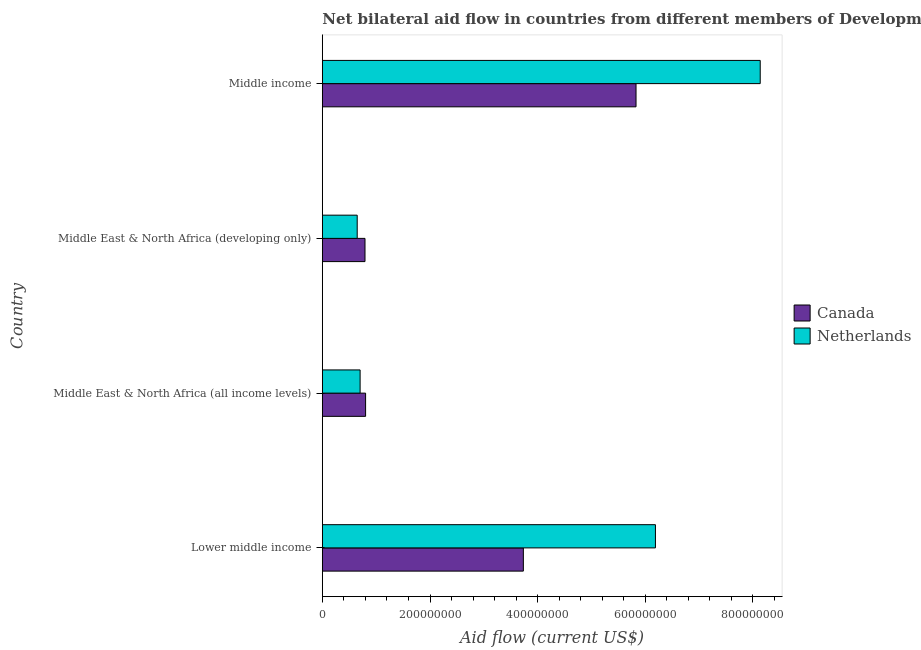Are the number of bars per tick equal to the number of legend labels?
Keep it short and to the point. Yes. How many bars are there on the 3rd tick from the top?
Offer a terse response. 2. What is the label of the 4th group of bars from the top?
Your answer should be very brief. Lower middle income. What is the amount of aid given by netherlands in Middle East & North Africa (all income levels)?
Provide a short and direct response. 7.02e+07. Across all countries, what is the maximum amount of aid given by netherlands?
Make the answer very short. 8.13e+08. Across all countries, what is the minimum amount of aid given by canada?
Provide a short and direct response. 7.93e+07. In which country was the amount of aid given by canada minimum?
Offer a very short reply. Middle East & North Africa (developing only). What is the total amount of aid given by netherlands in the graph?
Your answer should be compact. 1.57e+09. What is the difference between the amount of aid given by netherlands in Middle East & North Africa (all income levels) and that in Middle East & North Africa (developing only)?
Provide a succinct answer. 5.41e+06. What is the difference between the amount of aid given by canada in Middle income and the amount of aid given by netherlands in Middle East & North Africa (developing only)?
Provide a short and direct response. 5.18e+08. What is the average amount of aid given by netherlands per country?
Offer a terse response. 3.92e+08. What is the difference between the amount of aid given by netherlands and amount of aid given by canada in Middle income?
Provide a short and direct response. 2.31e+08. What is the ratio of the amount of aid given by netherlands in Lower middle income to that in Middle East & North Africa (developing only)?
Provide a short and direct response. 9.55. Is the difference between the amount of aid given by netherlands in Lower middle income and Middle East & North Africa (all income levels) greater than the difference between the amount of aid given by canada in Lower middle income and Middle East & North Africa (all income levels)?
Ensure brevity in your answer.  Yes. What is the difference between the highest and the second highest amount of aid given by canada?
Your answer should be very brief. 2.09e+08. What is the difference between the highest and the lowest amount of aid given by netherlands?
Your answer should be very brief. 7.49e+08. What does the 1st bar from the top in Middle income represents?
Your answer should be compact. Netherlands. Are all the bars in the graph horizontal?
Your answer should be compact. Yes. What is the difference between two consecutive major ticks on the X-axis?
Provide a succinct answer. 2.00e+08. Where does the legend appear in the graph?
Keep it short and to the point. Center right. How many legend labels are there?
Offer a terse response. 2. How are the legend labels stacked?
Provide a short and direct response. Vertical. What is the title of the graph?
Your answer should be very brief. Net bilateral aid flow in countries from different members of Development Assistance Committee. Does "Current US$" appear as one of the legend labels in the graph?
Your answer should be compact. No. What is the label or title of the Y-axis?
Provide a succinct answer. Country. What is the Aid flow (current US$) in Canada in Lower middle income?
Provide a succinct answer. 3.73e+08. What is the Aid flow (current US$) of Netherlands in Lower middle income?
Provide a short and direct response. 6.19e+08. What is the Aid flow (current US$) in Canada in Middle East & North Africa (all income levels)?
Ensure brevity in your answer.  8.04e+07. What is the Aid flow (current US$) of Netherlands in Middle East & North Africa (all income levels)?
Make the answer very short. 7.02e+07. What is the Aid flow (current US$) in Canada in Middle East & North Africa (developing only)?
Give a very brief answer. 7.93e+07. What is the Aid flow (current US$) of Netherlands in Middle East & North Africa (developing only)?
Keep it short and to the point. 6.48e+07. What is the Aid flow (current US$) in Canada in Middle income?
Offer a very short reply. 5.83e+08. What is the Aid flow (current US$) of Netherlands in Middle income?
Your answer should be compact. 8.13e+08. Across all countries, what is the maximum Aid flow (current US$) in Canada?
Give a very brief answer. 5.83e+08. Across all countries, what is the maximum Aid flow (current US$) of Netherlands?
Ensure brevity in your answer.  8.13e+08. Across all countries, what is the minimum Aid flow (current US$) in Canada?
Your response must be concise. 7.93e+07. Across all countries, what is the minimum Aid flow (current US$) in Netherlands?
Give a very brief answer. 6.48e+07. What is the total Aid flow (current US$) in Canada in the graph?
Your answer should be compact. 1.12e+09. What is the total Aid flow (current US$) in Netherlands in the graph?
Give a very brief answer. 1.57e+09. What is the difference between the Aid flow (current US$) of Canada in Lower middle income and that in Middle East & North Africa (all income levels)?
Your answer should be compact. 2.93e+08. What is the difference between the Aid flow (current US$) of Netherlands in Lower middle income and that in Middle East & North Africa (all income levels)?
Make the answer very short. 5.49e+08. What is the difference between the Aid flow (current US$) of Canada in Lower middle income and that in Middle East & North Africa (developing only)?
Offer a terse response. 2.94e+08. What is the difference between the Aid flow (current US$) of Netherlands in Lower middle income and that in Middle East & North Africa (developing only)?
Your answer should be very brief. 5.54e+08. What is the difference between the Aid flow (current US$) of Canada in Lower middle income and that in Middle income?
Provide a succinct answer. -2.09e+08. What is the difference between the Aid flow (current US$) of Netherlands in Lower middle income and that in Middle income?
Offer a very short reply. -1.95e+08. What is the difference between the Aid flow (current US$) of Canada in Middle East & North Africa (all income levels) and that in Middle East & North Africa (developing only)?
Your answer should be compact. 1.12e+06. What is the difference between the Aid flow (current US$) of Netherlands in Middle East & North Africa (all income levels) and that in Middle East & North Africa (developing only)?
Provide a short and direct response. 5.41e+06. What is the difference between the Aid flow (current US$) in Canada in Middle East & North Africa (all income levels) and that in Middle income?
Make the answer very short. -5.02e+08. What is the difference between the Aid flow (current US$) of Netherlands in Middle East & North Africa (all income levels) and that in Middle income?
Ensure brevity in your answer.  -7.43e+08. What is the difference between the Aid flow (current US$) in Canada in Middle East & North Africa (developing only) and that in Middle income?
Offer a terse response. -5.03e+08. What is the difference between the Aid flow (current US$) in Netherlands in Middle East & North Africa (developing only) and that in Middle income?
Offer a terse response. -7.49e+08. What is the difference between the Aid flow (current US$) of Canada in Lower middle income and the Aid flow (current US$) of Netherlands in Middle East & North Africa (all income levels)?
Offer a very short reply. 3.03e+08. What is the difference between the Aid flow (current US$) in Canada in Lower middle income and the Aid flow (current US$) in Netherlands in Middle East & North Africa (developing only)?
Provide a succinct answer. 3.09e+08. What is the difference between the Aid flow (current US$) of Canada in Lower middle income and the Aid flow (current US$) of Netherlands in Middle income?
Provide a succinct answer. -4.40e+08. What is the difference between the Aid flow (current US$) of Canada in Middle East & North Africa (all income levels) and the Aid flow (current US$) of Netherlands in Middle East & North Africa (developing only)?
Offer a terse response. 1.56e+07. What is the difference between the Aid flow (current US$) in Canada in Middle East & North Africa (all income levels) and the Aid flow (current US$) in Netherlands in Middle income?
Your answer should be compact. -7.33e+08. What is the difference between the Aid flow (current US$) of Canada in Middle East & North Africa (developing only) and the Aid flow (current US$) of Netherlands in Middle income?
Give a very brief answer. -7.34e+08. What is the average Aid flow (current US$) of Canada per country?
Give a very brief answer. 2.79e+08. What is the average Aid flow (current US$) of Netherlands per country?
Your answer should be very brief. 3.92e+08. What is the difference between the Aid flow (current US$) in Canada and Aid flow (current US$) in Netherlands in Lower middle income?
Give a very brief answer. -2.45e+08. What is the difference between the Aid flow (current US$) of Canada and Aid flow (current US$) of Netherlands in Middle East & North Africa (all income levels)?
Your answer should be compact. 1.02e+07. What is the difference between the Aid flow (current US$) of Canada and Aid flow (current US$) of Netherlands in Middle East & North Africa (developing only)?
Your answer should be compact. 1.45e+07. What is the difference between the Aid flow (current US$) in Canada and Aid flow (current US$) in Netherlands in Middle income?
Your answer should be compact. -2.31e+08. What is the ratio of the Aid flow (current US$) in Canada in Lower middle income to that in Middle East & North Africa (all income levels)?
Ensure brevity in your answer.  4.65. What is the ratio of the Aid flow (current US$) of Netherlands in Lower middle income to that in Middle East & North Africa (all income levels)?
Offer a terse response. 8.82. What is the ratio of the Aid flow (current US$) of Canada in Lower middle income to that in Middle East & North Africa (developing only)?
Offer a terse response. 4.71. What is the ratio of the Aid flow (current US$) in Netherlands in Lower middle income to that in Middle East & North Africa (developing only)?
Your answer should be very brief. 9.55. What is the ratio of the Aid flow (current US$) of Canada in Lower middle income to that in Middle income?
Provide a succinct answer. 0.64. What is the ratio of the Aid flow (current US$) in Netherlands in Lower middle income to that in Middle income?
Your answer should be compact. 0.76. What is the ratio of the Aid flow (current US$) in Canada in Middle East & North Africa (all income levels) to that in Middle East & North Africa (developing only)?
Offer a terse response. 1.01. What is the ratio of the Aid flow (current US$) of Netherlands in Middle East & North Africa (all income levels) to that in Middle East & North Africa (developing only)?
Offer a very short reply. 1.08. What is the ratio of the Aid flow (current US$) in Canada in Middle East & North Africa (all income levels) to that in Middle income?
Give a very brief answer. 0.14. What is the ratio of the Aid flow (current US$) of Netherlands in Middle East & North Africa (all income levels) to that in Middle income?
Ensure brevity in your answer.  0.09. What is the ratio of the Aid flow (current US$) of Canada in Middle East & North Africa (developing only) to that in Middle income?
Provide a succinct answer. 0.14. What is the ratio of the Aid flow (current US$) in Netherlands in Middle East & North Africa (developing only) to that in Middle income?
Your answer should be very brief. 0.08. What is the difference between the highest and the second highest Aid flow (current US$) of Canada?
Keep it short and to the point. 2.09e+08. What is the difference between the highest and the second highest Aid flow (current US$) of Netherlands?
Your response must be concise. 1.95e+08. What is the difference between the highest and the lowest Aid flow (current US$) in Canada?
Make the answer very short. 5.03e+08. What is the difference between the highest and the lowest Aid flow (current US$) of Netherlands?
Make the answer very short. 7.49e+08. 